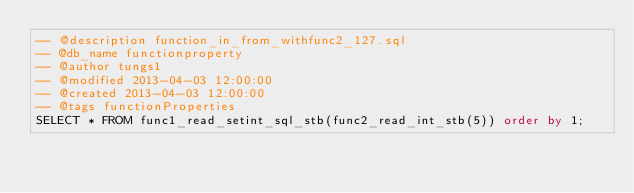Convert code to text. <code><loc_0><loc_0><loc_500><loc_500><_SQL_>-- @description function_in_from_withfunc2_127.sql
-- @db_name functionproperty
-- @author tungs1
-- @modified 2013-04-03 12:00:00
-- @created 2013-04-03 12:00:00
-- @tags functionProperties 
SELECT * FROM func1_read_setint_sql_stb(func2_read_int_stb(5)) order by 1; 
</code> 